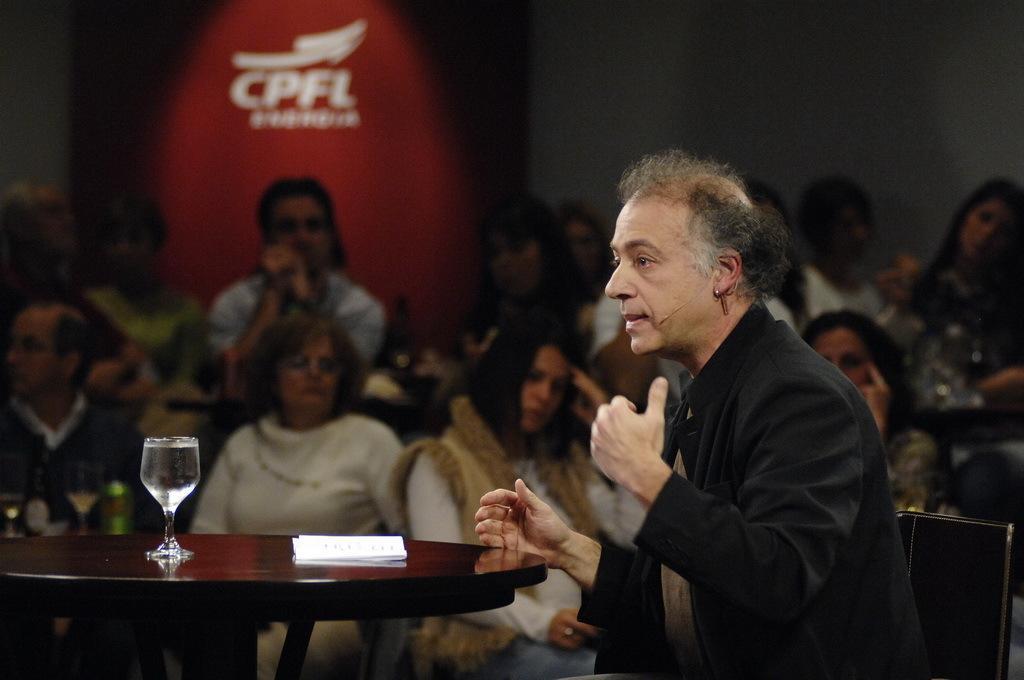Could you give a brief overview of what you see in this image? In this image I see a man who is sitting on a chair and I can also see that there is a table in front of him and there is a paper and a glass on it. In the background I can see lot of people. 